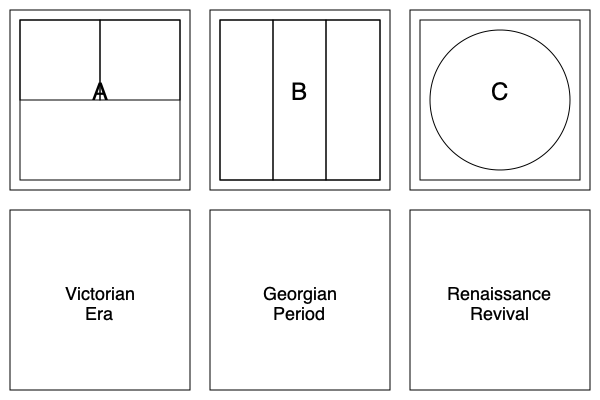Match the floor plans (A, B, C) to their corresponding historical periods (Victorian Era, Georgian Period, Renaissance Revival) based on typical architectural characteristics. 1. Floor Plan A:
   - Features a symmetrical layout with four equal-sized rooms
   - Typical of the Victorian Era (1837-1901)
   - Victorian homes often had a central hall with rooms branching off

2. Floor Plan B:
   - Shows a long, narrow layout with three rooms in a row
   - Characteristic of the Georgian Period (1714-1830)
   - Georgian townhouses often had this "shotgun" style layout

3. Floor Plan C:
   - Displays a circular central space with surrounding rooms
   - Indicative of the Renaissance Revival style (mid-19th to early 20th century)
   - Renaissance-inspired designs often incorporated classical elements like circular forms

Matching:
A - Victorian Era
B - Georgian Period
C - Renaissance Revival
Answer: A-Victorian, B-Georgian, C-Renaissance Revival 